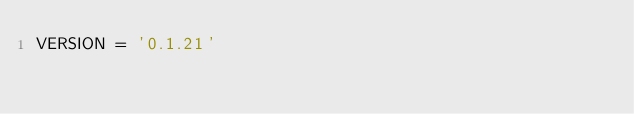<code> <loc_0><loc_0><loc_500><loc_500><_Python_>VERSION = '0.1.21'
</code> 